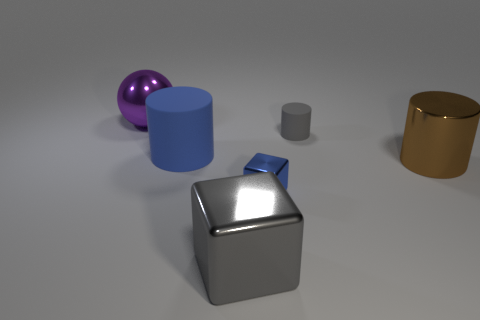Add 4 big rubber cylinders. How many objects exist? 10 Subtract all blocks. How many objects are left? 4 Subtract all cubes. Subtract all big red rubber blocks. How many objects are left? 4 Add 4 large metal things. How many large metal things are left? 7 Add 3 tiny red shiny balls. How many tiny red shiny balls exist? 3 Subtract 0 cyan spheres. How many objects are left? 6 